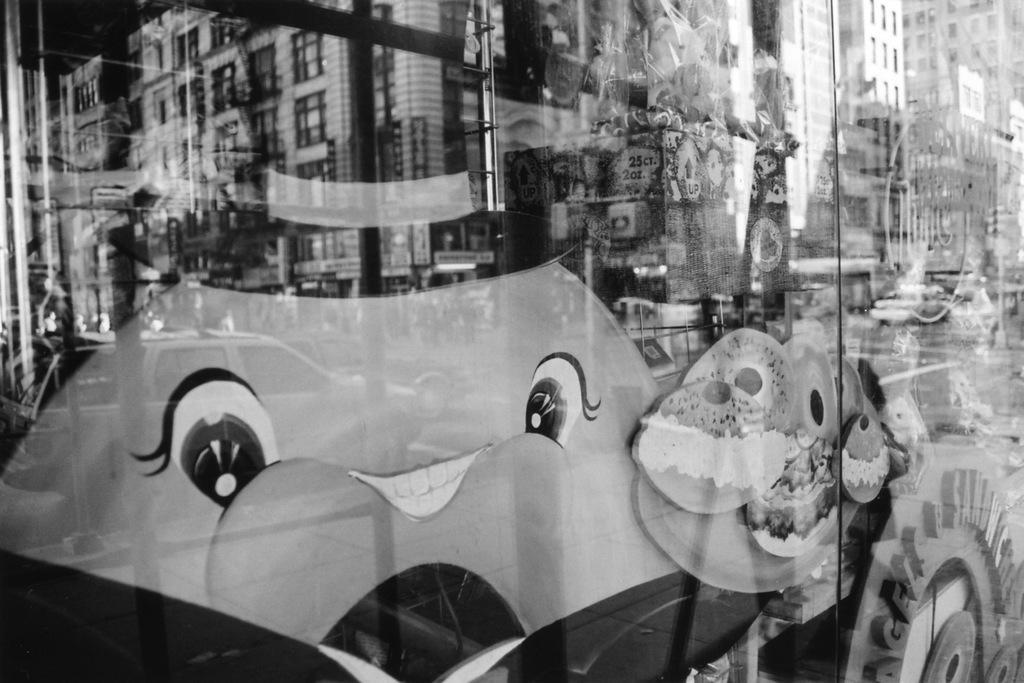How would you summarize this image in a sentence or two? In this image in the foreground there is a glass door and through the door we could see some buildings, trees and some other objects. And in the background also there are some other objects. 